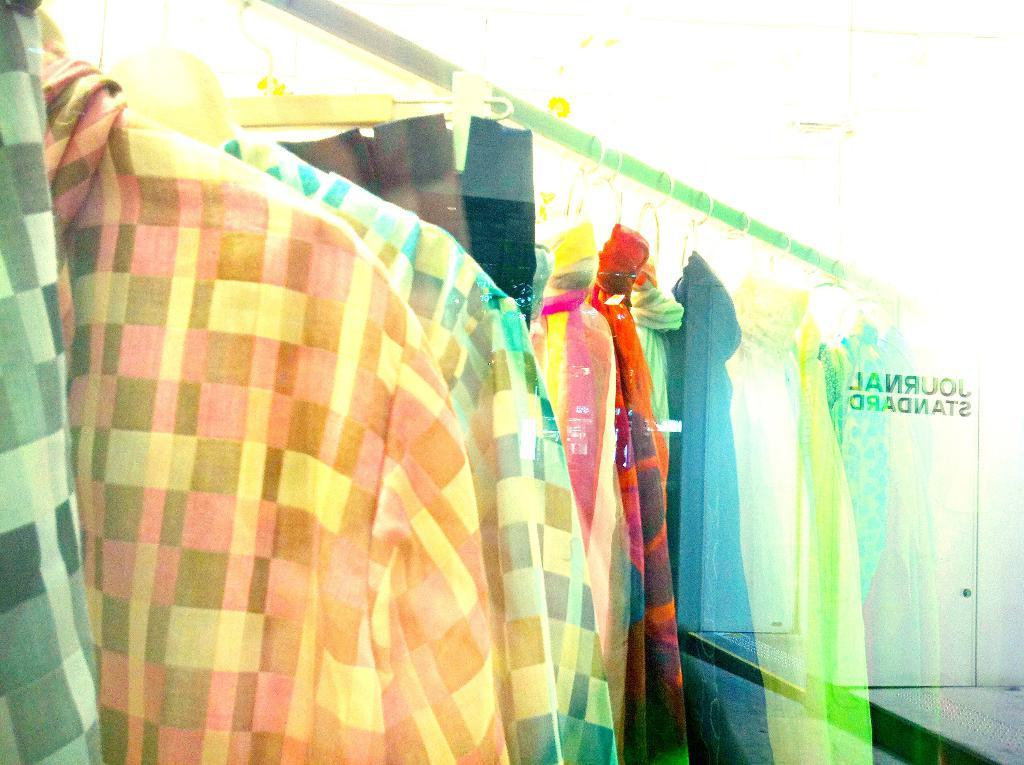What type of clothing items can be seen in the image? There are shirts in the image. How are the shirts arranged in the image? The shirts are on hangers. Where are the shirts located in the image? The shirts are located in the center of the image. What color is the fog surrounding the shirts in the image? There is no fog present in the image; it features shirts on hangers in the center. 